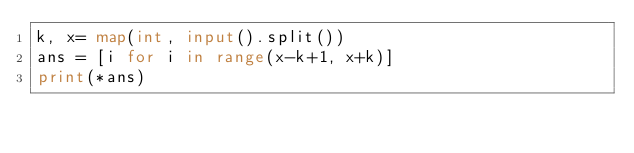<code> <loc_0><loc_0><loc_500><loc_500><_Python_>k, x= map(int, input().split())
ans = [i for i in range(x-k+1, x+k)]
print(*ans)</code> 